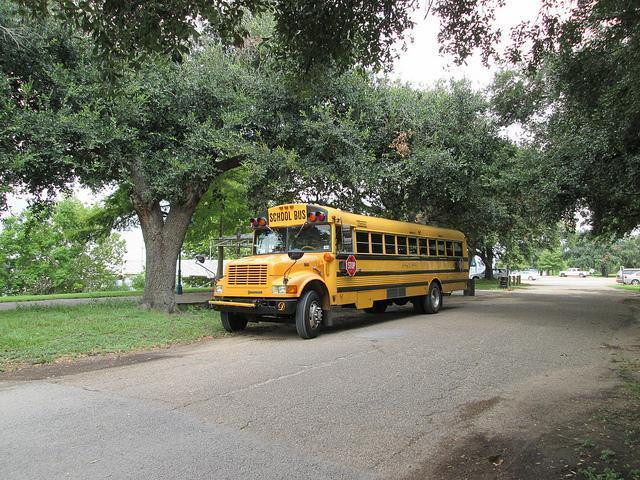How many school buses are shown?
Give a very brief answer. 1. How many clocks are on the tower?
Give a very brief answer. 0. 